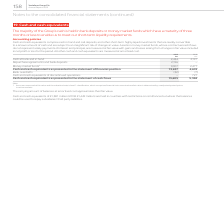According to Vodafone Group Plc's financial document, How long is the maturity period of the group's money market funds? three months or less. The document states: "ts or money market funds which have a maturity of three months or less to enable us to meet our short-term liquidity requirements...." Also, What does cash and cash equivalents comprise of? cash in hand and call deposits, and other short-term highly liquid investments that are readily convertible to a known amount of cash and are subject to an insignificant risk of changes in value. The document states: "nting policies Cash and cash equivalents comprise cash in hand and call deposits, and other short-term highly liquid investments that are readily conv..." Also, How much is the 2019 cash at bank and hand ? According to the financial document, 2,434 (in millions). The relevant text states: "2019 2018 €m €m Cash at bank and in hand 2,434 2,197 Repurchase agreements and bank deposits 2,196 – Money market funds 1 9,007 2,477 Cash and cas..." Additionally, Between 2018 and 2019, which year had a greater amount of cash at bank and in hand? According to the financial document, 2019. The relevant text states: "2019 2018 €m €m Cash at bank and in hand 2,434 2,197 Repurchase agreements and bank deposits 2,196 – Mon..." Also, can you calculate: What is the average money market funds? To answer this question, I need to perform calculations using the financial data. The calculation is: (9,007+2,477)/2, which equals 5742 (in millions). This is based on the information: "bank deposits 2,196 – Money market funds 1 9,007 2,477 Cash and cash equivalents as presented in the statement of financial position 13,637 4,674 Bank ove ts and bank deposits 2,196 – Money market fun..." The key data points involved are: 2,477, 9,007. Also, can you calculate: What is the average cash and cash equivalents presented in the statement of cash flows? To answer this question, I need to perform calculations using the financial data. The calculation is: (13,605+5,394)/2, which equals 9499.5 (in millions). This is based on the information: "s presented in the statement of cash flows 13,605 5,394 lents as presented in the statement of cash flows 13,605 5,394..." The key data points involved are: 13,605, 5,394. 